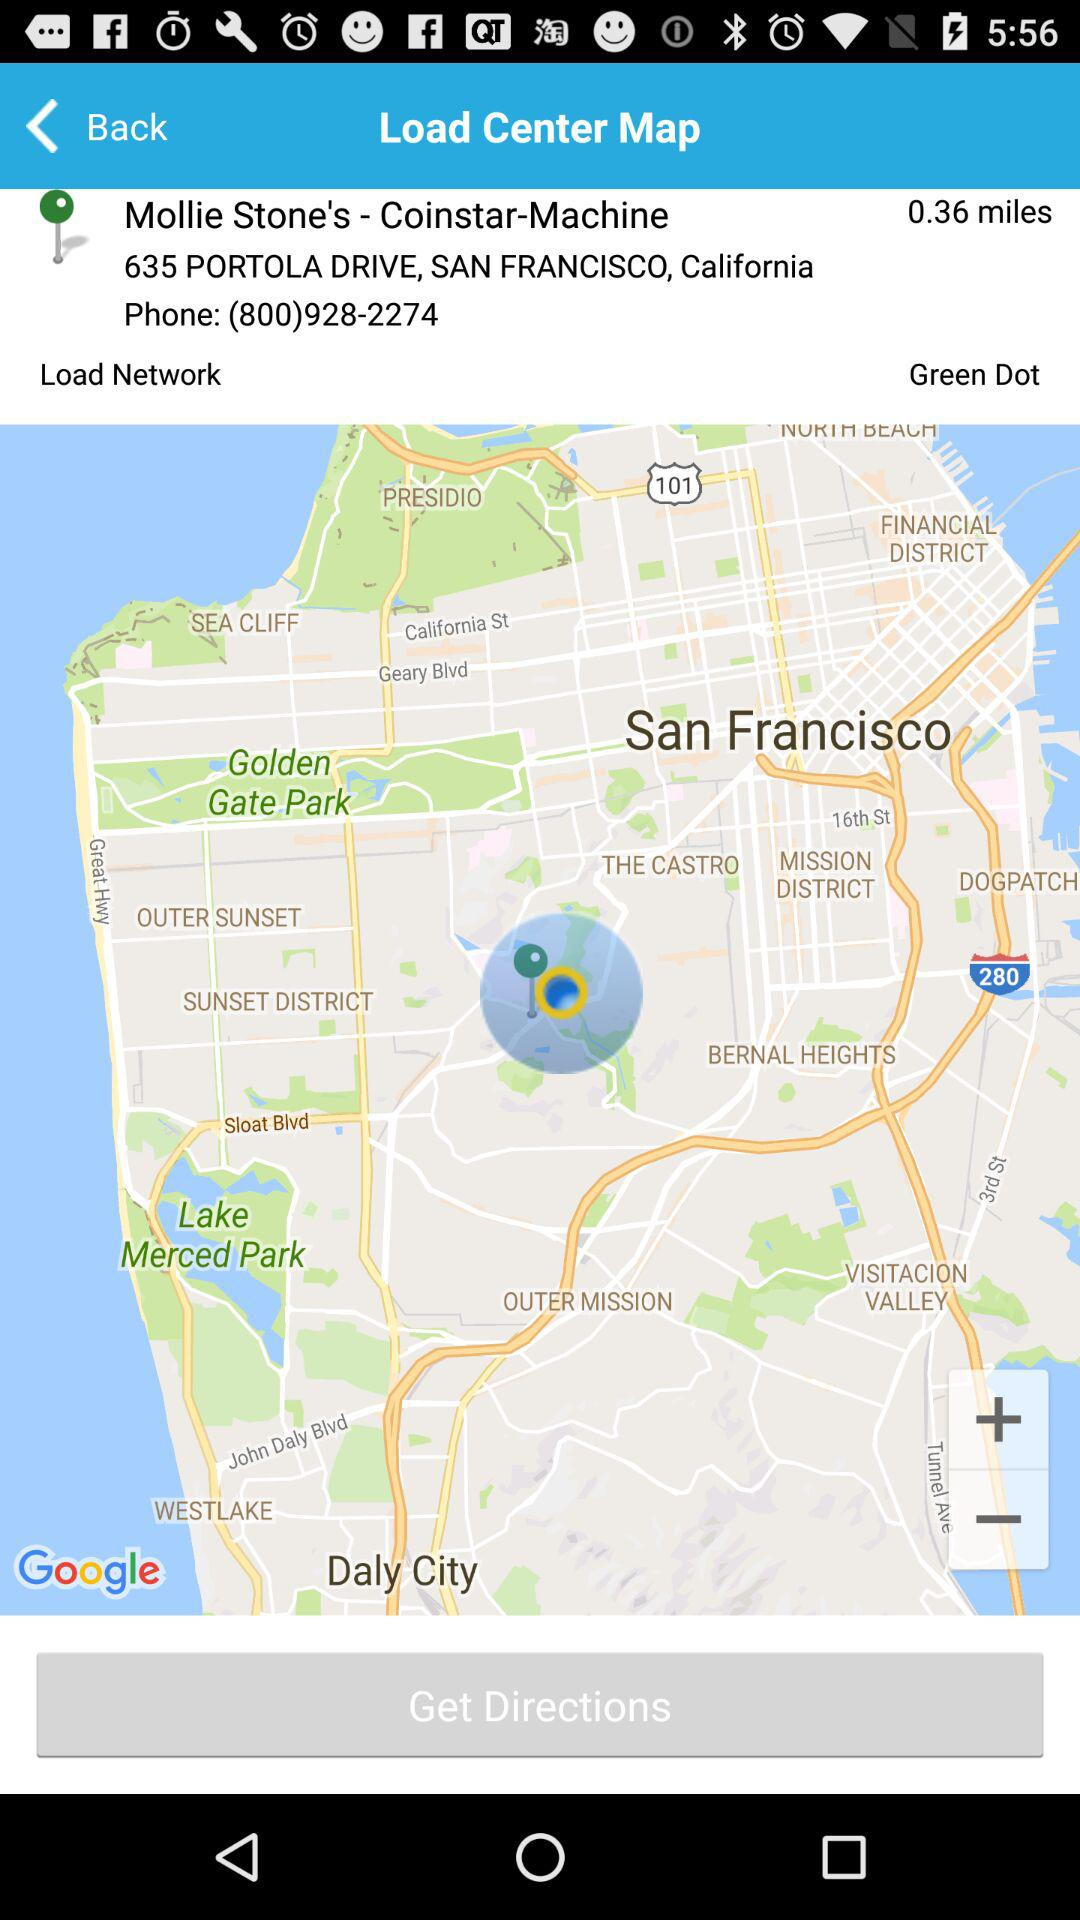How much is the given distance? The given distance is 0.36 miles. 